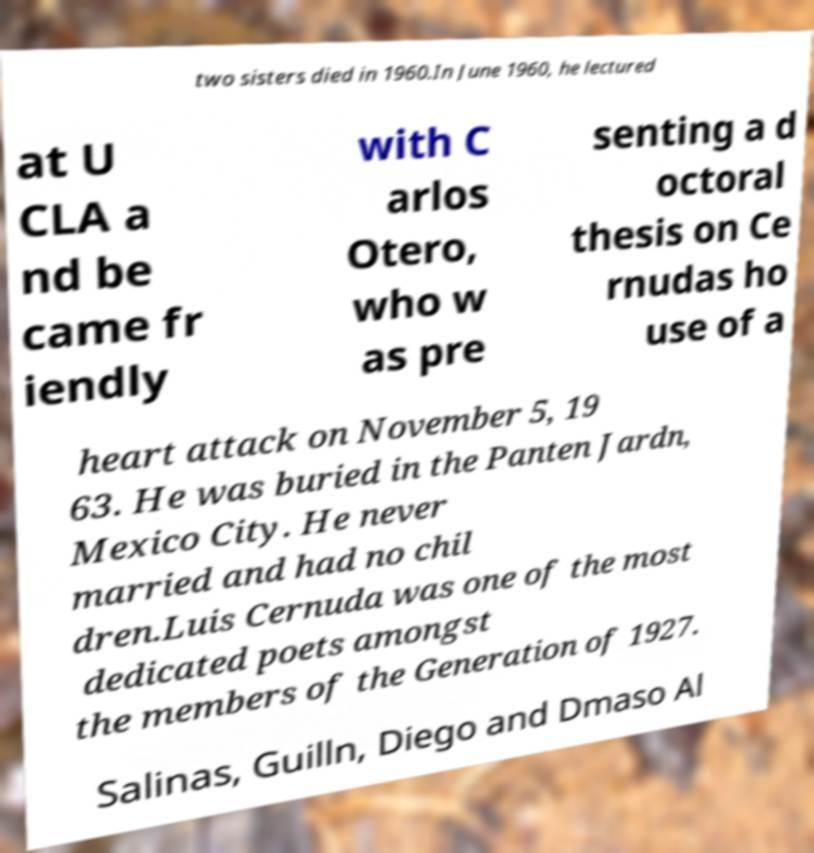Please read and relay the text visible in this image. What does it say? two sisters died in 1960.In June 1960, he lectured at U CLA a nd be came fr iendly with C arlos Otero, who w as pre senting a d octoral thesis on Ce rnudas ho use of a heart attack on November 5, 19 63. He was buried in the Panten Jardn, Mexico City. He never married and had no chil dren.Luis Cernuda was one of the most dedicated poets amongst the members of the Generation of 1927. Salinas, Guilln, Diego and Dmaso Al 